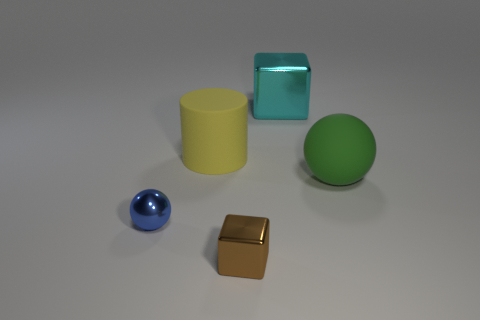Add 3 tiny blue shiny things. How many objects exist? 8 Subtract all blue balls. How many balls are left? 1 Subtract 1 blocks. How many blocks are left? 1 Add 2 green matte spheres. How many green matte spheres exist? 3 Subtract 1 cyan blocks. How many objects are left? 4 Subtract all blocks. How many objects are left? 3 Subtract all gray balls. Subtract all yellow cubes. How many balls are left? 2 Subtract all cyan balls. How many purple blocks are left? 0 Subtract all large gray metallic things. Subtract all big yellow rubber cylinders. How many objects are left? 4 Add 1 yellow objects. How many yellow objects are left? 2 